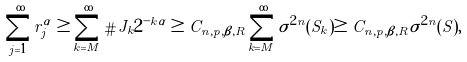Convert formula to latex. <formula><loc_0><loc_0><loc_500><loc_500>\sum _ { j = 1 } ^ { \infty } r _ { j } ^ { \alpha } \geq \sum _ { k = M } ^ { \infty } \# J _ { k } 2 ^ { - k \alpha } \geq C _ { n , p , \beta , R } \sum _ { k = M } ^ { \infty } \sigma ^ { 2 n } ( S _ { k } ) \geq C _ { n , p , \beta , R } \sigma ^ { 2 n } ( S ) ,</formula> 